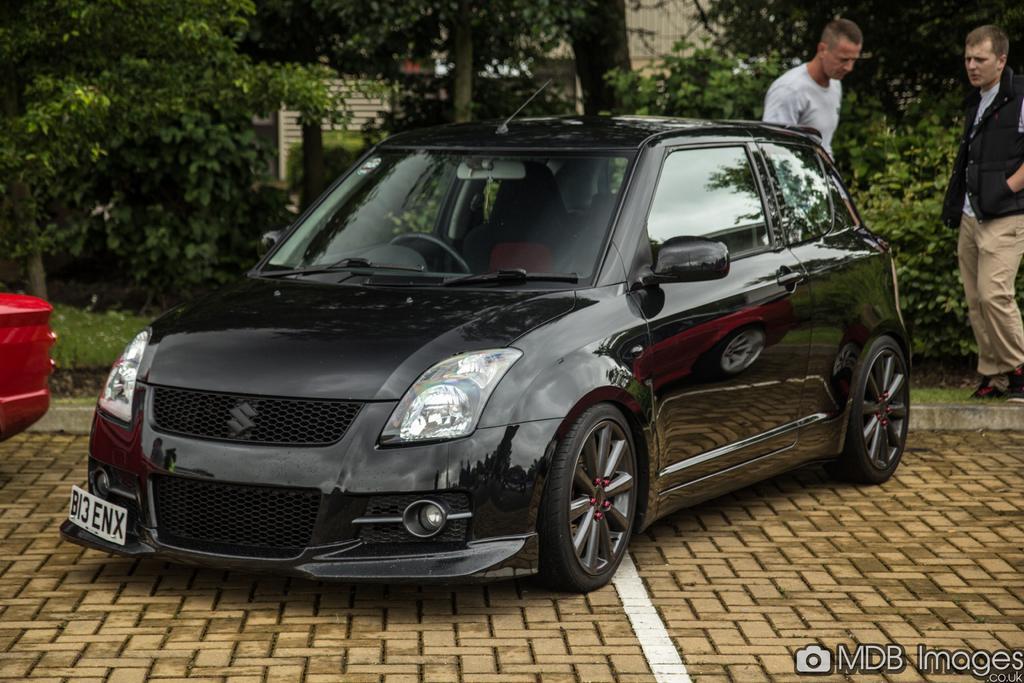In one or two sentences, can you explain what this image depicts? In the image we can see a vehicle, black in color, these are the headlight and number plate of the vehicle. There are two men standing, they are wearing clothes, this is a footpath, grass, plant and trees. This is a watermark. 